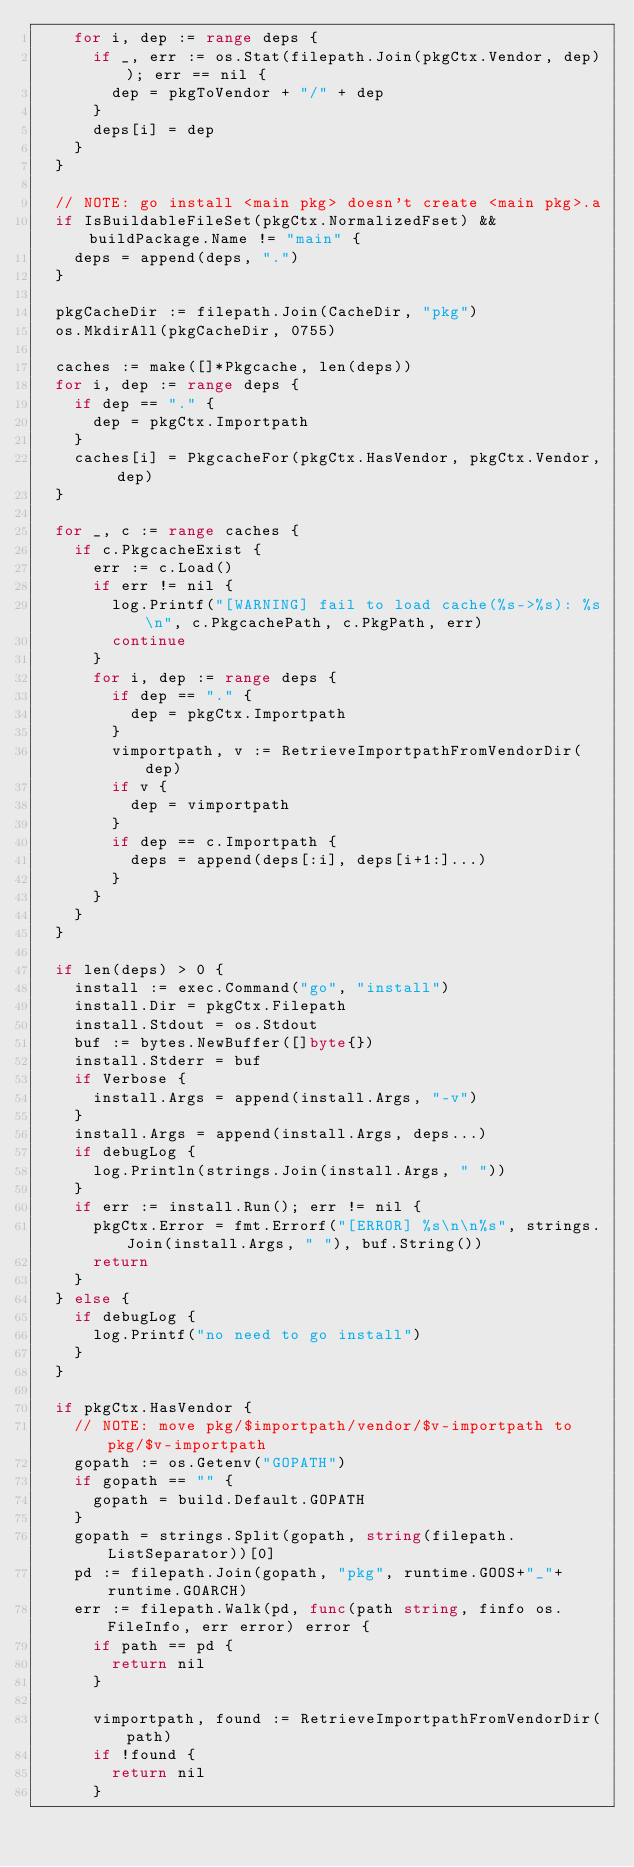<code> <loc_0><loc_0><loc_500><loc_500><_Go_>		for i, dep := range deps {
			if _, err := os.Stat(filepath.Join(pkgCtx.Vendor, dep)); err == nil {
				dep = pkgToVendor + "/" + dep
			}
			deps[i] = dep
		}
	}

	// NOTE: go install <main pkg> doesn't create <main pkg>.a
	if IsBuildableFileSet(pkgCtx.NormalizedFset) && buildPackage.Name != "main" {
		deps = append(deps, ".")
	}

	pkgCacheDir := filepath.Join(CacheDir, "pkg")
	os.MkdirAll(pkgCacheDir, 0755)

	caches := make([]*Pkgcache, len(deps))
	for i, dep := range deps {
		if dep == "." {
			dep = pkgCtx.Importpath
		}
		caches[i] = PkgcacheFor(pkgCtx.HasVendor, pkgCtx.Vendor, dep)
	}

	for _, c := range caches {
		if c.PkgcacheExist {
			err := c.Load()
			if err != nil {
				log.Printf("[WARNING] fail to load cache(%s->%s): %s\n", c.PkgcachePath, c.PkgPath, err)
				continue
			}
			for i, dep := range deps {
				if dep == "." {
					dep = pkgCtx.Importpath
				}
				vimportpath, v := RetrieveImportpathFromVendorDir(dep)
				if v {
					dep = vimportpath
				}
				if dep == c.Importpath {
					deps = append(deps[:i], deps[i+1:]...)
				}
			}
		}
	}

	if len(deps) > 0 {
		install := exec.Command("go", "install")
		install.Dir = pkgCtx.Filepath
		install.Stdout = os.Stdout
		buf := bytes.NewBuffer([]byte{})
		install.Stderr = buf
		if Verbose {
			install.Args = append(install.Args, "-v")
		}
		install.Args = append(install.Args, deps...)
		if debugLog {
			log.Println(strings.Join(install.Args, " "))
		}
		if err := install.Run(); err != nil {
			pkgCtx.Error = fmt.Errorf("[ERROR] %s\n\n%s", strings.Join(install.Args, " "), buf.String())
			return
		}
	} else {
		if debugLog {
			log.Printf("no need to go install")
		}
	}

	if pkgCtx.HasVendor {
		// NOTE: move pkg/$importpath/vendor/$v-importpath to pkg/$v-importpath
		gopath := os.Getenv("GOPATH")
		if gopath == "" {
			gopath = build.Default.GOPATH
		}
		gopath = strings.Split(gopath, string(filepath.ListSeparator))[0]
		pd := filepath.Join(gopath, "pkg", runtime.GOOS+"_"+runtime.GOARCH)
		err := filepath.Walk(pd, func(path string, finfo os.FileInfo, err error) error {
			if path == pd {
				return nil
			}

			vimportpath, found := RetrieveImportpathFromVendorDir(path)
			if !found {
				return nil
			}
</code> 